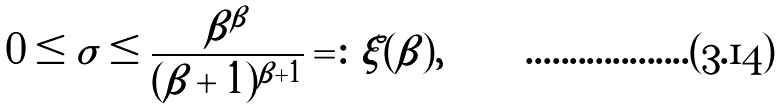<formula> <loc_0><loc_0><loc_500><loc_500>0 \leq \sigma \leq \frac { \beta ^ { \beta } } { ( \beta + 1 ) ^ { \beta + 1 } } = \colon \xi ( \beta ) ,</formula> 